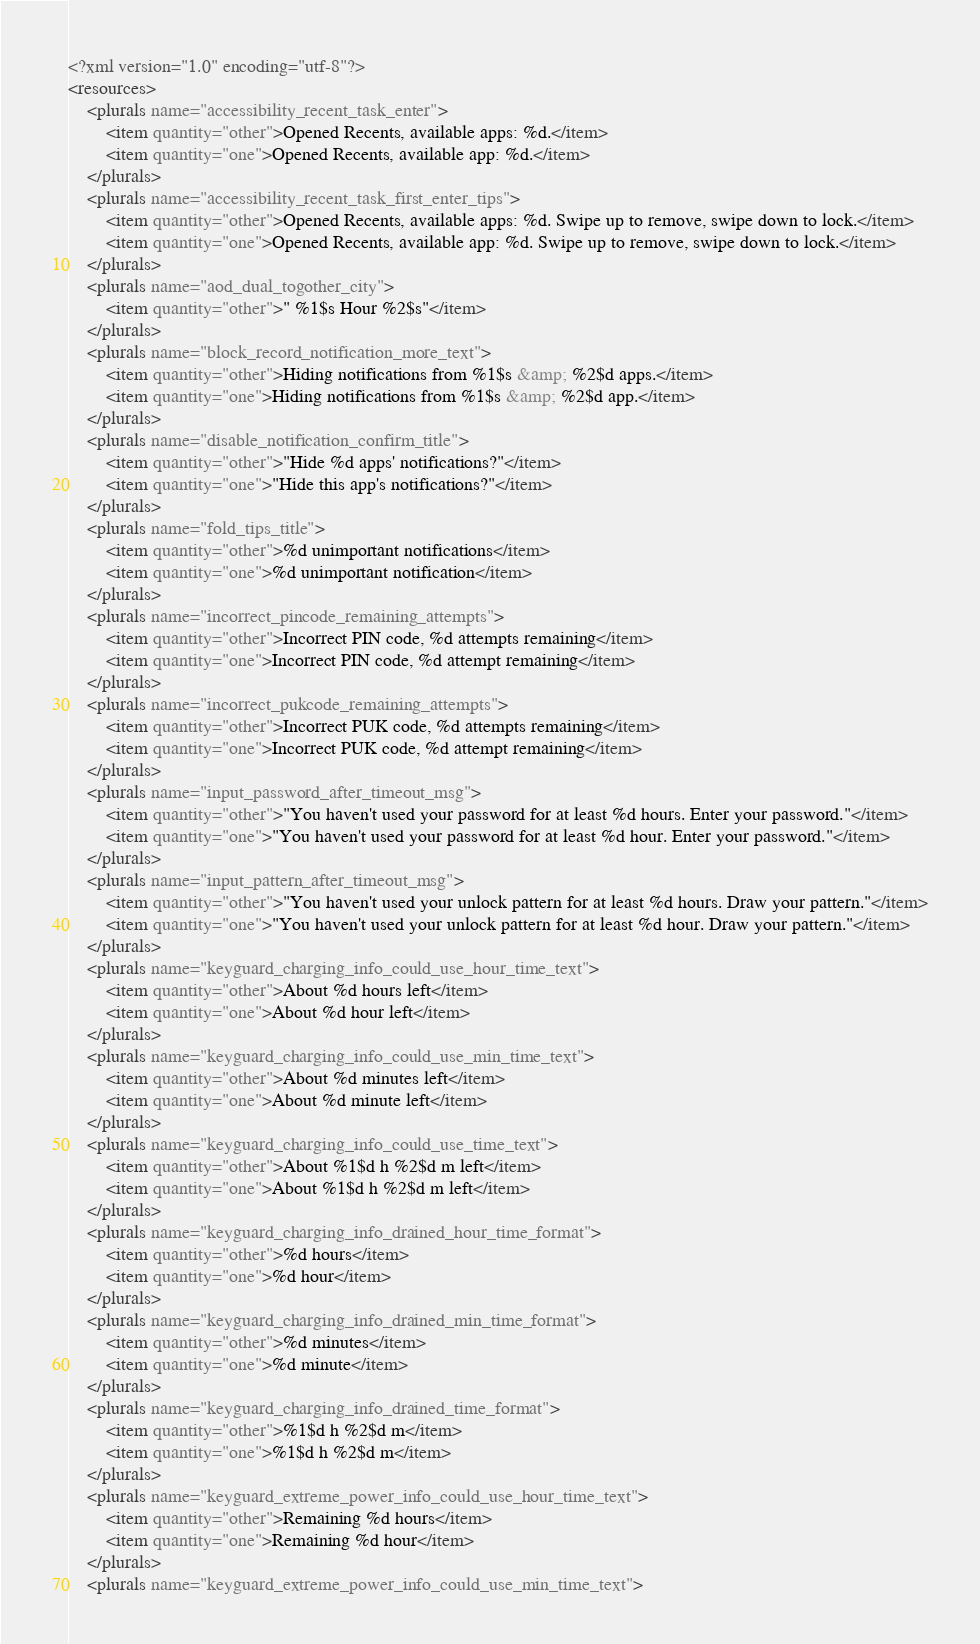<code> <loc_0><loc_0><loc_500><loc_500><_XML_><?xml version="1.0" encoding="utf-8"?>
<resources>
    <plurals name="accessibility_recent_task_enter">
        <item quantity="other">Opened Recents, available apps: %d.</item>
        <item quantity="one">Opened Recents, available app: %d.</item>
    </plurals>
    <plurals name="accessibility_recent_task_first_enter_tips">
        <item quantity="other">Opened Recents, available apps: %d. Swipe up to remove, swipe down to lock.</item>
        <item quantity="one">Opened Recents, available app: %d. Swipe up to remove, swipe down to lock.</item>
    </plurals>
    <plurals name="aod_dual_togother_city">
        <item quantity="other">" %1$s Hour %2$s"</item>
    </plurals>
    <plurals name="block_record_notification_more_text">
        <item quantity="other">Hiding notifications from %1$s &amp; %2$d apps.</item>
        <item quantity="one">Hiding notifications from %1$s &amp; %2$d app.</item>
    </plurals>
    <plurals name="disable_notification_confirm_title">
        <item quantity="other">"Hide %d apps' notifications?"</item>
        <item quantity="one">"Hide this app's notifications?"</item>
    </plurals>
    <plurals name="fold_tips_title">
        <item quantity="other">%d unimportant notifications</item>
        <item quantity="one">%d unimportant notification</item>
    </plurals>
    <plurals name="incorrect_pincode_remaining_attempts">
        <item quantity="other">Incorrect PIN code, %d attempts remaining</item>
        <item quantity="one">Incorrect PIN code, %d attempt remaining</item>
    </plurals>
    <plurals name="incorrect_pukcode_remaining_attempts">
        <item quantity="other">Incorrect PUK code, %d attempts remaining</item>
        <item quantity="one">Incorrect PUK code, %d attempt remaining</item>
    </plurals>
    <plurals name="input_password_after_timeout_msg">
        <item quantity="other">"You haven't used your password for at least %d hours. Enter your password."</item>
        <item quantity="one">"You haven't used your password for at least %d hour. Enter your password."</item>
    </plurals>
    <plurals name="input_pattern_after_timeout_msg">
        <item quantity="other">"You haven't used your unlock pattern for at least %d hours. Draw your pattern."</item>
        <item quantity="one">"You haven't used your unlock pattern for at least %d hour. Draw your pattern."</item>
    </plurals>
    <plurals name="keyguard_charging_info_could_use_hour_time_text">
        <item quantity="other">About %d hours left</item>
        <item quantity="one">About %d hour left</item>
    </plurals>
    <plurals name="keyguard_charging_info_could_use_min_time_text">
        <item quantity="other">About %d minutes left</item>
        <item quantity="one">About %d minute left</item>
    </plurals>
    <plurals name="keyguard_charging_info_could_use_time_text">
        <item quantity="other">About %1$d h %2$d m left</item>
        <item quantity="one">About %1$d h %2$d m left</item>
    </plurals>
    <plurals name="keyguard_charging_info_drained_hour_time_format">
        <item quantity="other">%d hours</item>
        <item quantity="one">%d hour</item>
    </plurals>
    <plurals name="keyguard_charging_info_drained_min_time_format">
        <item quantity="other">%d minutes</item>
        <item quantity="one">%d minute</item>
    </plurals>
    <plurals name="keyguard_charging_info_drained_time_format">
        <item quantity="other">%1$d h %2$d m</item>
        <item quantity="one">%1$d h %2$d m</item>
    </plurals>
    <plurals name="keyguard_extreme_power_info_could_use_hour_time_text">
        <item quantity="other">Remaining %d hours</item>
        <item quantity="one">Remaining %d hour</item>
    </plurals>
    <plurals name="keyguard_extreme_power_info_could_use_min_time_text"></code> 